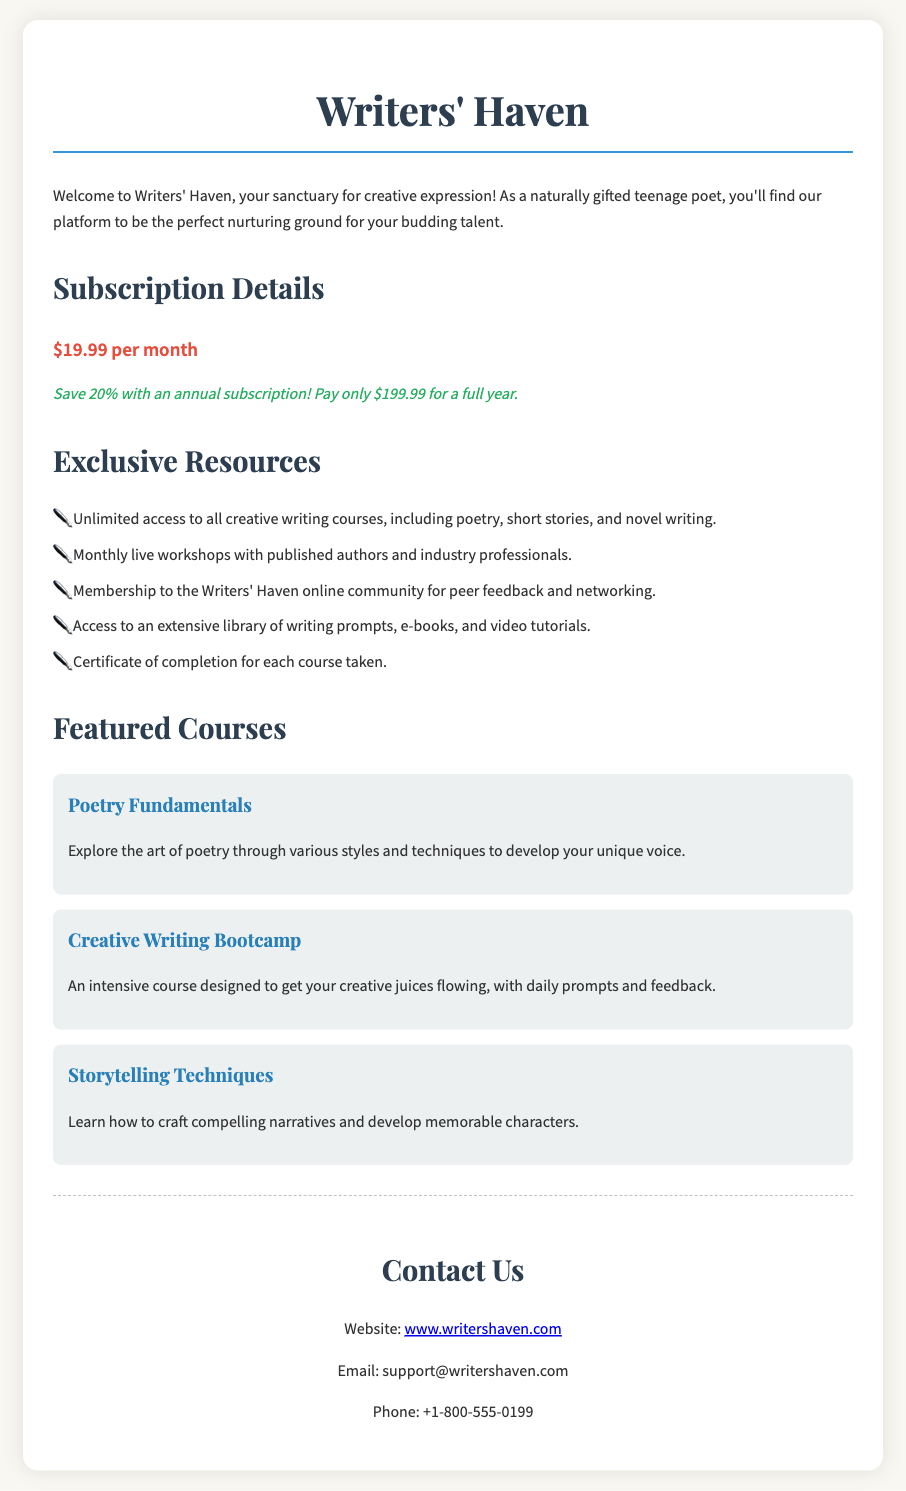What is the monthly fee? The document specifies the monthly fee for the subscription service as $19.99.
Answer: $19.99 What discount do you get with an annual subscription? The document mentions that there is a 20% discount for an annual subscription.
Answer: 20% What is the annual subscription fee? The document states that the fee for a full year with the annual subscription is $199.99.
Answer: $199.99 How many featured courses are listed? The document lists three featured courses under the section "Featured Courses."
Answer: 3 What type of access do members get to live workshops? Members have access to monthly live workshops with published authors and industry professionals.
Answer: Monthly What can members receive after completing a course? According to the document, members can receive a certificate of completion for each course taken.
Answer: Certificate What is the title of the first featured course? The first featured course listed in the document is "Poetry Fundamentals."
Answer: Poetry Fundamentals What online community benefit is included in the subscription? The document indicates that members gain membership to the Writers' Haven online community for peer feedback and networking.
Answer: Peer feedback and networking Where can you find more information online? The document provides the website link for more information, which is www.writershaven.com.
Answer: www.writershaven.com 